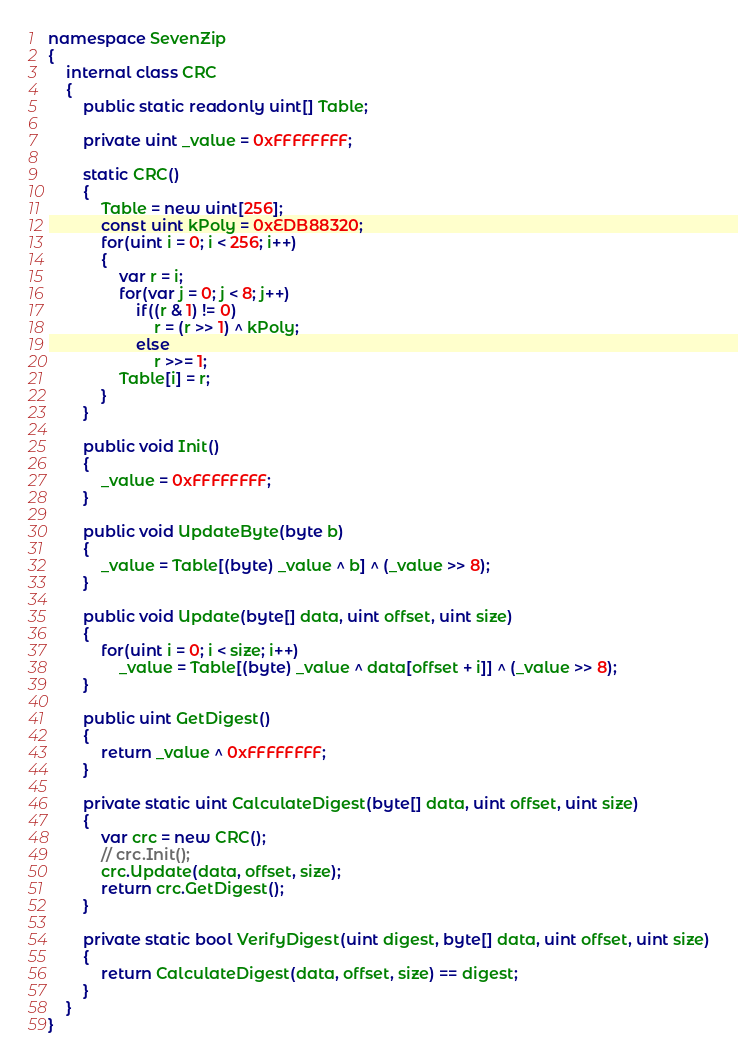<code> <loc_0><loc_0><loc_500><loc_500><_C#_>namespace SevenZip
{
    internal class CRC
    {
        public static readonly uint[] Table;

        private uint _value = 0xFFFFFFFF;

        static CRC()
        {
            Table = new uint[256];
            const uint kPoly = 0xEDB88320;
            for(uint i = 0; i < 256; i++)
            {
                var r = i;
                for(var j = 0; j < 8; j++)
                    if((r & 1) != 0)
                        r = (r >> 1) ^ kPoly;
                    else
                        r >>= 1;
                Table[i] = r;
            }
        }

        public void Init()
        {
            _value = 0xFFFFFFFF;
        }

        public void UpdateByte(byte b)
        {
            _value = Table[(byte) _value ^ b] ^ (_value >> 8);
        }

        public void Update(byte[] data, uint offset, uint size)
        {
            for(uint i = 0; i < size; i++)
                _value = Table[(byte) _value ^ data[offset + i]] ^ (_value >> 8);
        }

        public uint GetDigest()
        {
            return _value ^ 0xFFFFFFFF;
        }

        private static uint CalculateDigest(byte[] data, uint offset, uint size)
        {
            var crc = new CRC();
            // crc.Init();
            crc.Update(data, offset, size);
            return crc.GetDigest();
        }

        private static bool VerifyDigest(uint digest, byte[] data, uint offset, uint size)
        {
            return CalculateDigest(data, offset, size) == digest;
        }
    }
}</code> 